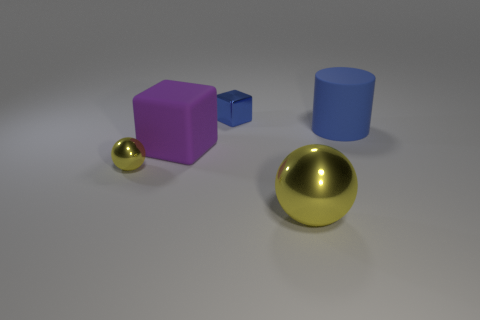There is a yellow shiny object in front of the metallic sphere that is to the left of the tiny shiny cube; is there a blue object that is left of it?
Ensure brevity in your answer.  Yes. What is the blue object that is in front of the blue thing behind the blue matte object made of?
Offer a terse response. Rubber. The large thing that is both to the right of the blue shiny block and behind the small yellow thing is made of what material?
Your answer should be compact. Rubber. Is there a large blue matte object that has the same shape as the blue metallic thing?
Offer a terse response. No. Are there any shiny balls that are in front of the yellow metallic thing behind the large sphere?
Offer a terse response. Yes. How many small yellow objects have the same material as the small cube?
Your response must be concise. 1. Are any small purple metallic objects visible?
Provide a short and direct response. No. What number of big matte blocks are the same color as the matte cylinder?
Provide a succinct answer. 0. Are the tiny yellow ball and the blue thing on the left side of the large yellow metallic thing made of the same material?
Keep it short and to the point. Yes. Is the number of large metallic things that are behind the large shiny ball greater than the number of purple blocks?
Keep it short and to the point. No. 